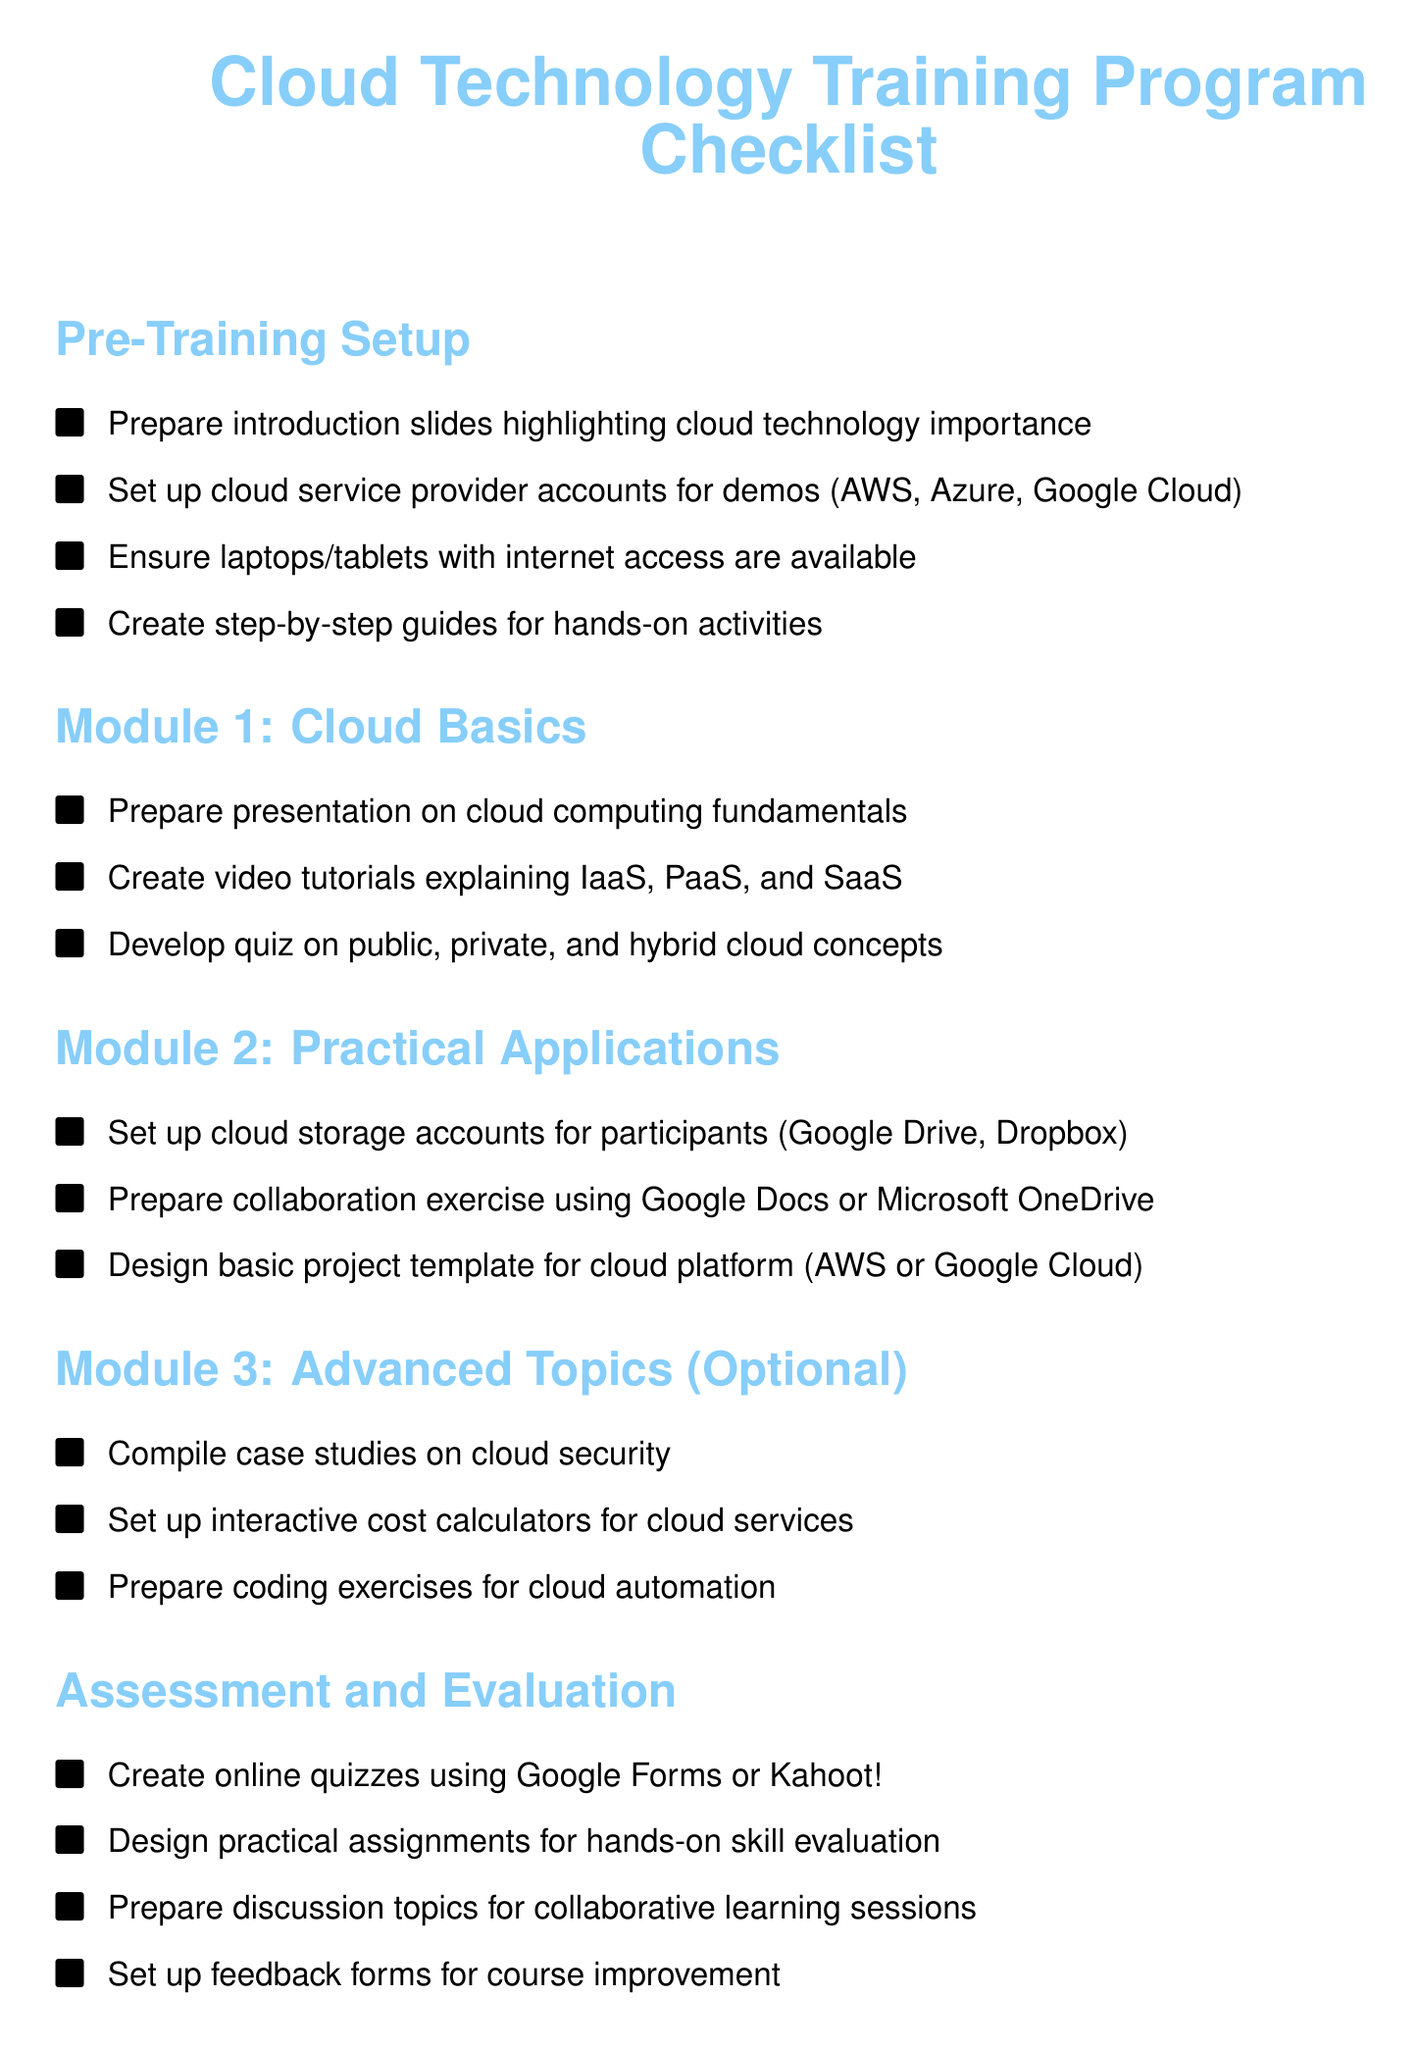What is the title of the checklist? The title of the checklist is presented at the top of the document.
Answer: Cloud Technology Training Program Checklist How many modules are included in the training program? The document lists three main modules and one optional module.
Answer: 3 What cloud service accounts are set up for practical applications? The document specifies cloud storage accounts that participants will set up during the training.
Answer: Google Drive, Dropbox Which platform is mentioned for creating online quizzes? The document includes specific platforms where online quizzes can be created.
Answer: Google Forms or Kahoot! What is the purpose of the feedback forms? The feedback forms are mentioned in the context of course improvement.
Answer: Course improvement Which specific advanced topic is available optionally? The document lists specific advanced topics offered at the discretion of the training organizers.
Answer: Cloud security 